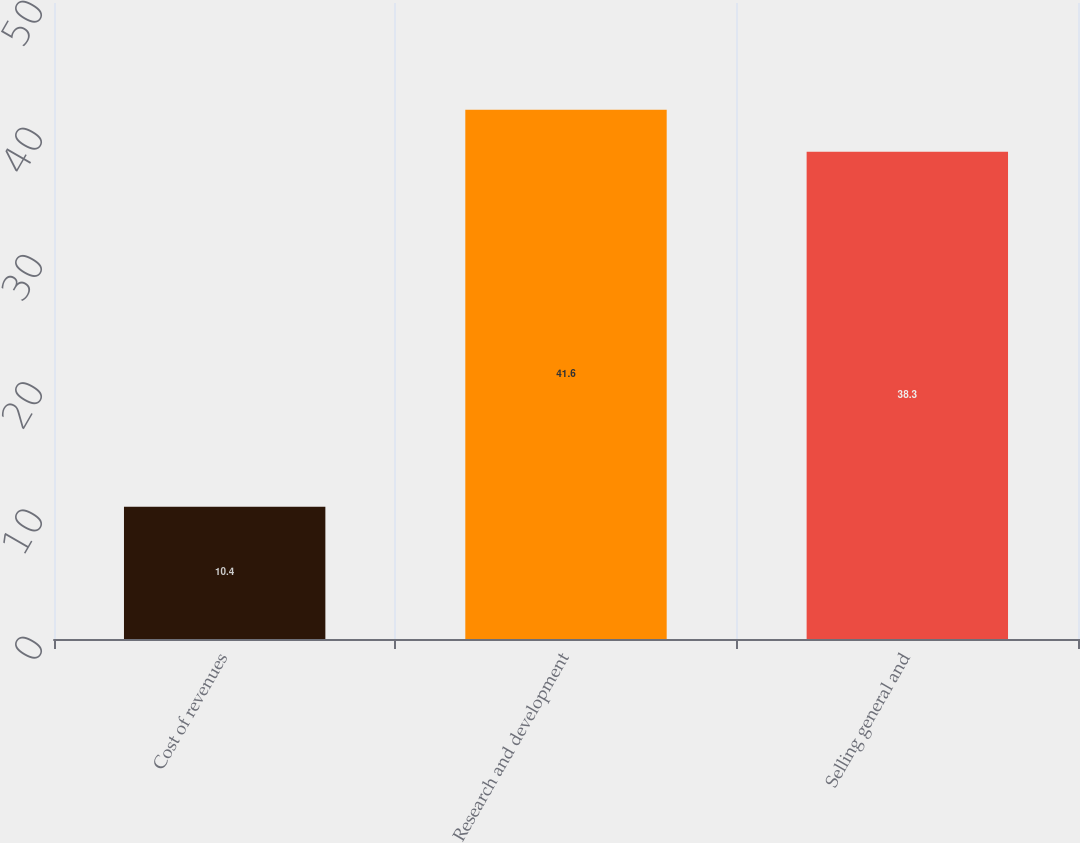Convert chart to OTSL. <chart><loc_0><loc_0><loc_500><loc_500><bar_chart><fcel>Cost of revenues<fcel>Research and development<fcel>Selling general and<nl><fcel>10.4<fcel>41.6<fcel>38.3<nl></chart> 